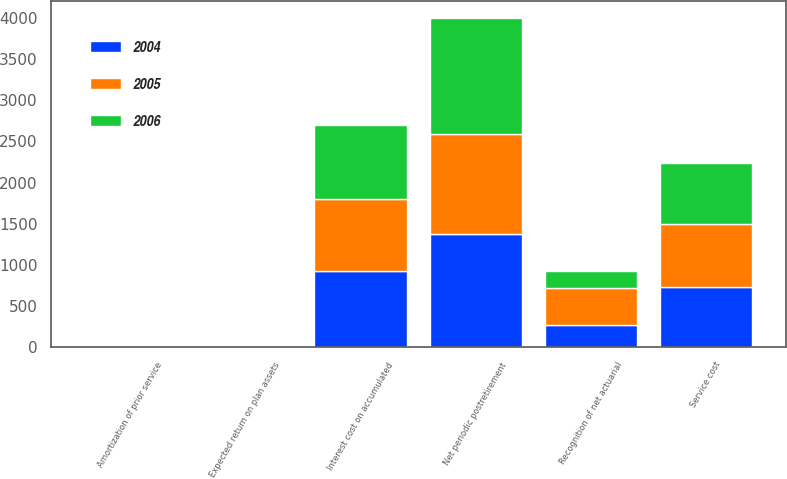Convert chart to OTSL. <chart><loc_0><loc_0><loc_500><loc_500><stacked_bar_chart><ecel><fcel>Service cost<fcel>Interest cost on accumulated<fcel>Expected return on plan assets<fcel>Amortization of prior service<fcel>Recognition of net actuarial<fcel>Net periodic postretirement<nl><fcel>2004<fcel>731<fcel>927<fcel>0<fcel>0<fcel>278<fcel>1380<nl><fcel>2006<fcel>735<fcel>891<fcel>0<fcel>0<fcel>211<fcel>1415<nl><fcel>2005<fcel>768<fcel>879<fcel>0<fcel>0<fcel>440<fcel>1207<nl></chart> 